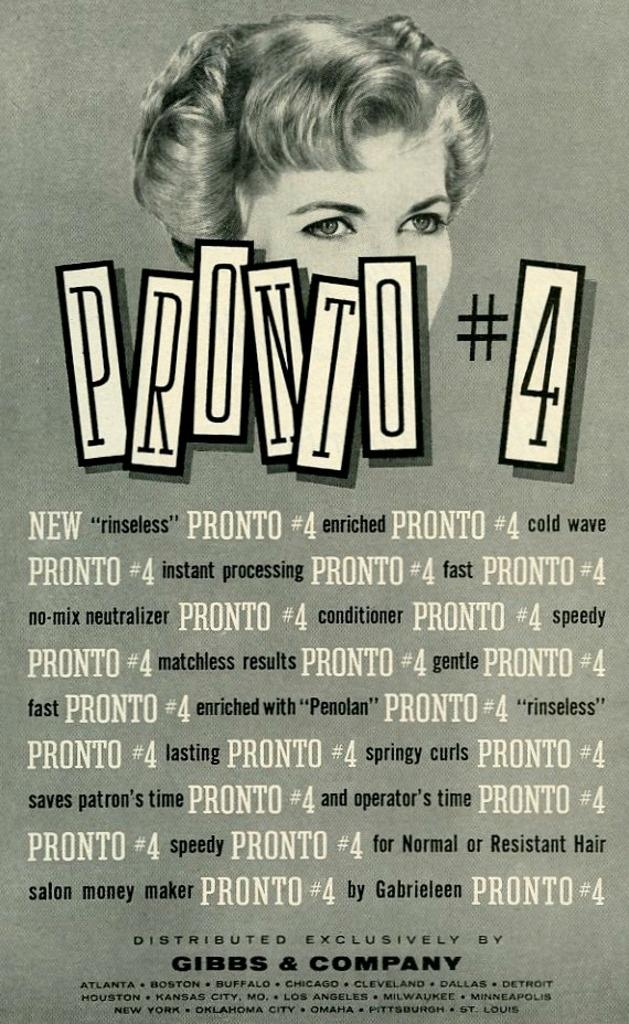<image>
Offer a succinct explanation of the picture presented. a prunto number 4 sign that has many numbers 